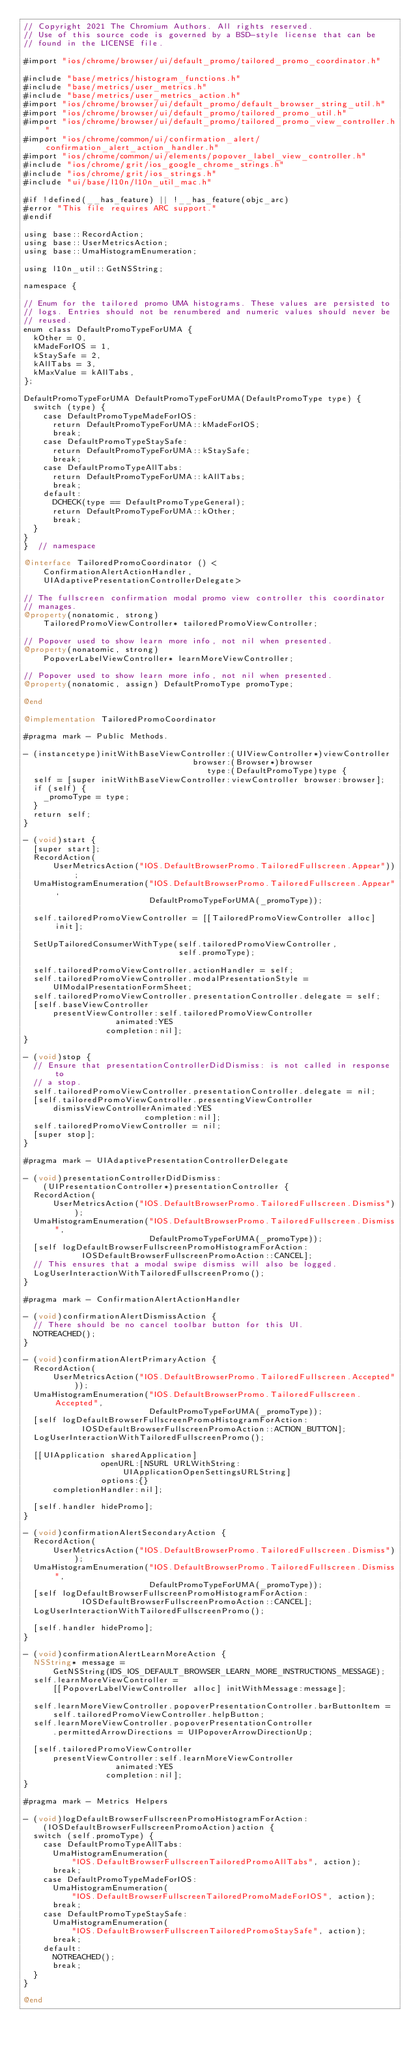<code> <loc_0><loc_0><loc_500><loc_500><_ObjectiveC_>// Copyright 2021 The Chromium Authors. All rights reserved.
// Use of this source code is governed by a BSD-style license that can be
// found in the LICENSE file.

#import "ios/chrome/browser/ui/default_promo/tailored_promo_coordinator.h"

#include "base/metrics/histogram_functions.h"
#include "base/metrics/user_metrics.h"
#include "base/metrics/user_metrics_action.h"
#import "ios/chrome/browser/ui/default_promo/default_browser_string_util.h"
#import "ios/chrome/browser/ui/default_promo/tailored_promo_util.h"
#import "ios/chrome/browser/ui/default_promo/tailored_promo_view_controller.h"
#import "ios/chrome/common/ui/confirmation_alert/confirmation_alert_action_handler.h"
#import "ios/chrome/common/ui/elements/popover_label_view_controller.h"
#include "ios/chrome/grit/ios_google_chrome_strings.h"
#include "ios/chrome/grit/ios_strings.h"
#include "ui/base/l10n/l10n_util_mac.h"

#if !defined(__has_feature) || !__has_feature(objc_arc)
#error "This file requires ARC support."
#endif

using base::RecordAction;
using base::UserMetricsAction;
using base::UmaHistogramEnumeration;

using l10n_util::GetNSString;

namespace {

// Enum for the tailored promo UMA histograms. These values are persisted to
// logs. Entries should not be renumbered and numeric values should never be
// reused.
enum class DefaultPromoTypeForUMA {
  kOther = 0,
  kMadeForIOS = 1,
  kStaySafe = 2,
  kAllTabs = 3,
  kMaxValue = kAllTabs,
};

DefaultPromoTypeForUMA DefaultPromoTypeForUMA(DefaultPromoType type) {
  switch (type) {
    case DefaultPromoTypeMadeForIOS:
      return DefaultPromoTypeForUMA::kMadeForIOS;
      break;
    case DefaultPromoTypeStaySafe:
      return DefaultPromoTypeForUMA::kStaySafe;
      break;
    case DefaultPromoTypeAllTabs:
      return DefaultPromoTypeForUMA::kAllTabs;
      break;
    default:
      DCHECK(type == DefaultPromoTypeGeneral);
      return DefaultPromoTypeForUMA::kOther;
      break;
  }
}
}  // namespace

@interface TailoredPromoCoordinator () <
    ConfirmationAlertActionHandler,
    UIAdaptivePresentationControllerDelegate>

// The fullscreen confirmation modal promo view controller this coordinator
// manages.
@property(nonatomic, strong)
    TailoredPromoViewController* tailoredPromoViewController;

// Popover used to show learn more info, not nil when presented.
@property(nonatomic, strong)
    PopoverLabelViewController* learnMoreViewController;

// Popover used to show learn more info, not nil when presented.
@property(nonatomic, assign) DefaultPromoType promoType;

@end

@implementation TailoredPromoCoordinator

#pragma mark - Public Methods.

- (instancetype)initWithBaseViewController:(UIViewController*)viewController
                                   browser:(Browser*)browser
                                      type:(DefaultPromoType)type {
  self = [super initWithBaseViewController:viewController browser:browser];
  if (self) {
    _promoType = type;
  }
  return self;
}

- (void)start {
  [super start];
  RecordAction(
      UserMetricsAction("IOS.DefaultBrowserPromo.TailoredFullscreen.Appear"));
  UmaHistogramEnumeration("IOS.DefaultBrowserPromo.TailoredFullscreen.Appear",
                          DefaultPromoTypeForUMA(_promoType));

  self.tailoredPromoViewController = [[TailoredPromoViewController alloc] init];

  SetUpTailoredConsumerWithType(self.tailoredPromoViewController,
                                self.promoType);

  self.tailoredPromoViewController.actionHandler = self;
  self.tailoredPromoViewController.modalPresentationStyle =
      UIModalPresentationFormSheet;
  self.tailoredPromoViewController.presentationController.delegate = self;
  [self.baseViewController
      presentViewController:self.tailoredPromoViewController
                   animated:YES
                 completion:nil];
}

- (void)stop {
  // Ensure that presentationControllerDidDismiss: is not called in response to
  // a stop.
  self.tailoredPromoViewController.presentationController.delegate = nil;
  [self.tailoredPromoViewController.presentingViewController
      dismissViewControllerAnimated:YES
                         completion:nil];
  self.tailoredPromoViewController = nil;
  [super stop];
}

#pragma mark - UIAdaptivePresentationControllerDelegate

- (void)presentationControllerDidDismiss:
    (UIPresentationController*)presentationController {
  RecordAction(
      UserMetricsAction("IOS.DefaultBrowserPromo.TailoredFullscreen.Dismiss"));
  UmaHistogramEnumeration("IOS.DefaultBrowserPromo.TailoredFullscreen.Dismiss",
                          DefaultPromoTypeForUMA(_promoType));
  [self logDefaultBrowserFullscreenPromoHistogramForAction:
            IOSDefaultBrowserFullscreenPromoAction::CANCEL];
  // This ensures that a modal swipe dismiss will also be logged.
  LogUserInteractionWithTailoredFullscreenPromo();
}

#pragma mark - ConfirmationAlertActionHandler

- (void)confirmationAlertDismissAction {
  // There should be no cancel toolbar button for this UI.
  NOTREACHED();
}

- (void)confirmationAlertPrimaryAction {
  RecordAction(
      UserMetricsAction("IOS.DefaultBrowserPromo.TailoredFullscreen.Accepted"));
  UmaHistogramEnumeration("IOS.DefaultBrowserPromo.TailoredFullscreen.Accepted",
                          DefaultPromoTypeForUMA(_promoType));
  [self logDefaultBrowserFullscreenPromoHistogramForAction:
            IOSDefaultBrowserFullscreenPromoAction::ACTION_BUTTON];
  LogUserInteractionWithTailoredFullscreenPromo();

  [[UIApplication sharedApplication]
                openURL:[NSURL URLWithString:UIApplicationOpenSettingsURLString]
                options:{}
      completionHandler:nil];

  [self.handler hidePromo];
}

- (void)confirmationAlertSecondaryAction {
  RecordAction(
      UserMetricsAction("IOS.DefaultBrowserPromo.TailoredFullscreen.Dismiss"));
  UmaHistogramEnumeration("IOS.DefaultBrowserPromo.TailoredFullscreen.Dismiss",
                          DefaultPromoTypeForUMA(_promoType));
  [self logDefaultBrowserFullscreenPromoHistogramForAction:
            IOSDefaultBrowserFullscreenPromoAction::CANCEL];
  LogUserInteractionWithTailoredFullscreenPromo();

  [self.handler hidePromo];
}

- (void)confirmationAlertLearnMoreAction {
  NSString* message =
      GetNSString(IDS_IOS_DEFAULT_BROWSER_LEARN_MORE_INSTRUCTIONS_MESSAGE);
  self.learnMoreViewController =
      [[PopoverLabelViewController alloc] initWithMessage:message];

  self.learnMoreViewController.popoverPresentationController.barButtonItem =
      self.tailoredPromoViewController.helpButton;
  self.learnMoreViewController.popoverPresentationController
      .permittedArrowDirections = UIPopoverArrowDirectionUp;

  [self.tailoredPromoViewController
      presentViewController:self.learnMoreViewController
                   animated:YES
                 completion:nil];
}

#pragma mark - Metrics Helpers

- (void)logDefaultBrowserFullscreenPromoHistogramForAction:
    (IOSDefaultBrowserFullscreenPromoAction)action {
  switch (self.promoType) {
    case DefaultPromoTypeAllTabs:
      UmaHistogramEnumeration(
          "IOS.DefaultBrowserFullscreenTailoredPromoAllTabs", action);
      break;
    case DefaultPromoTypeMadeForIOS:
      UmaHistogramEnumeration(
          "IOS.DefaultBrowserFullscreenTailoredPromoMadeForIOS", action);
      break;
    case DefaultPromoTypeStaySafe:
      UmaHistogramEnumeration(
          "IOS.DefaultBrowserFullscreenTailoredPromoStaySafe", action);
      break;
    default:
      NOTREACHED();
      break;
  }
}

@end
</code> 